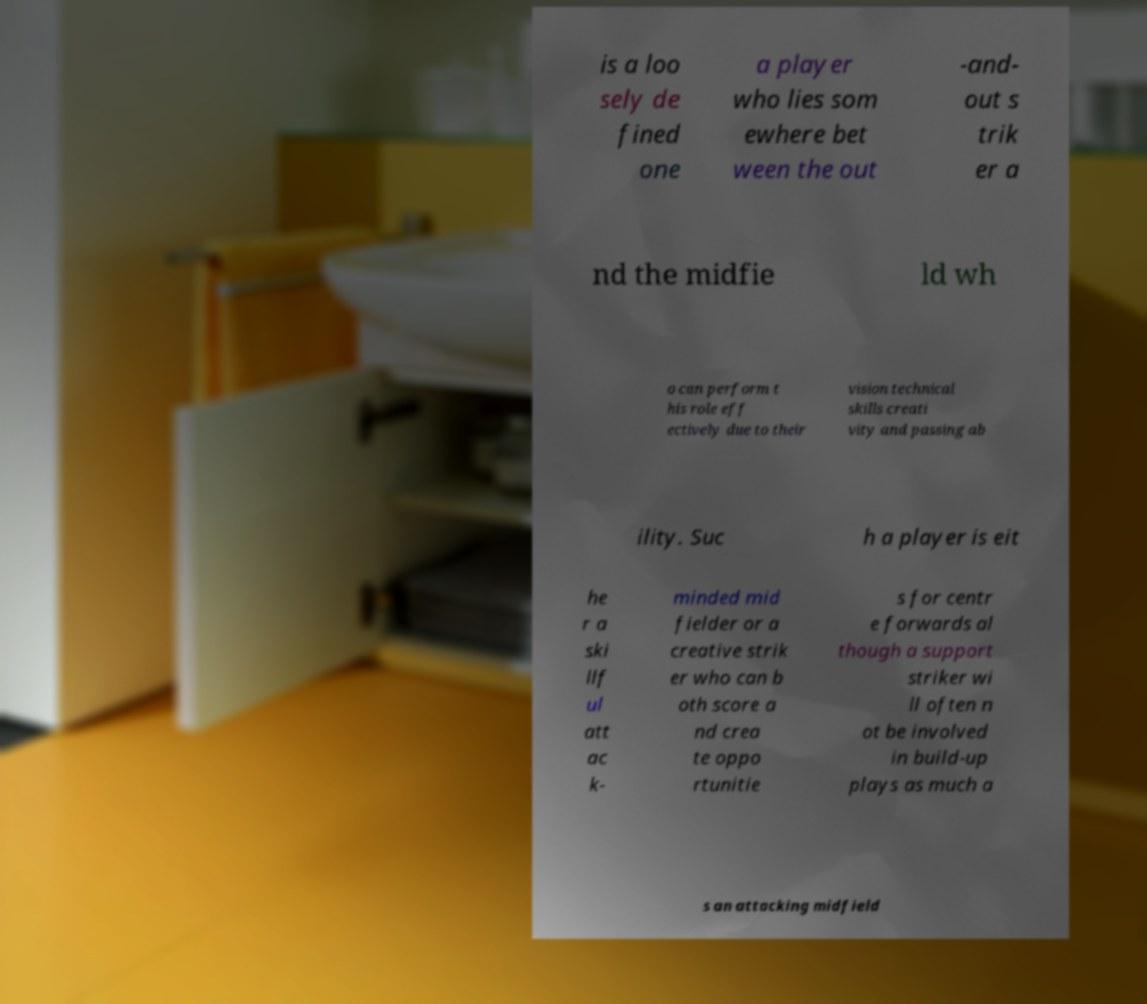Please read and relay the text visible in this image. What does it say? is a loo sely de fined one a player who lies som ewhere bet ween the out -and- out s trik er a nd the midfie ld wh o can perform t his role eff ectively due to their vision technical skills creati vity and passing ab ility. Suc h a player is eit he r a ski llf ul att ac k- minded mid fielder or a creative strik er who can b oth score a nd crea te oppo rtunitie s for centr e forwards al though a support striker wi ll often n ot be involved in build-up plays as much a s an attacking midfield 